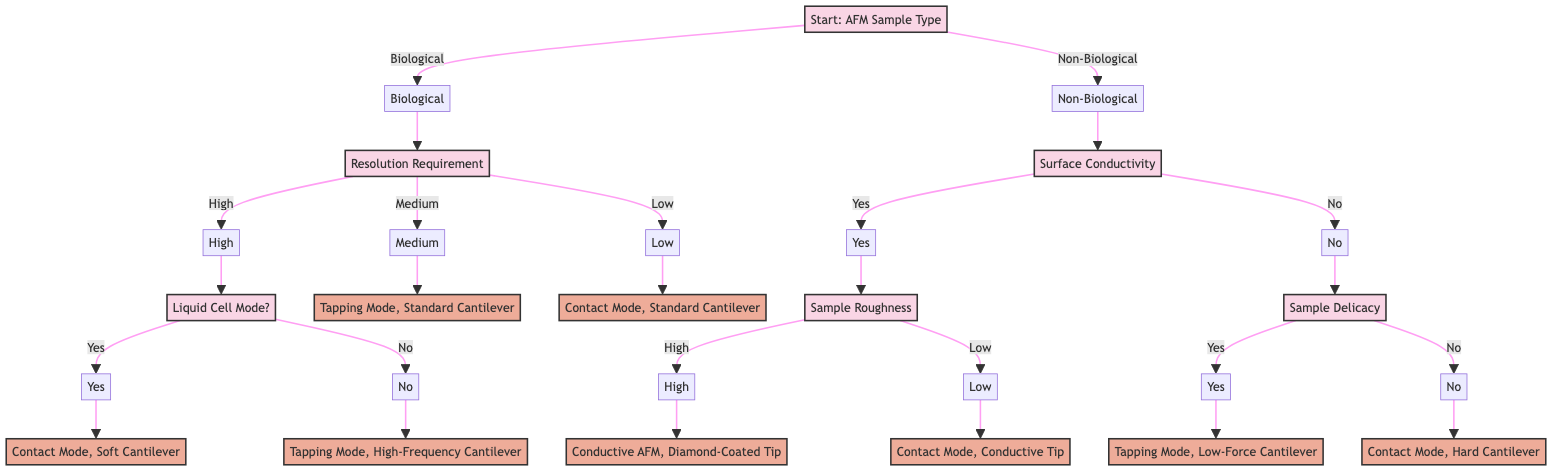What is the first question in the decision tree? The first question at the root node of the diagram asks about the type of sample being imaged, which can be either "Biological" or "Non-Biological."
Answer: What type of sample are you imaging? What are the resolution options available for biological samples? For biological samples, there are three resolution options listed: "High," "Medium," and "Low." Each of these options leads to different actions regarding AFM settings.
Answer: High, Medium, Low If the sample is non-biological and conductive, what does the tree ask next? After confirming that the sample is non-biological and conductive, the next question asked is about the roughness of the sample. This narrows down the AFM settings needed based on the roughness.
Answer: What is the roughness of the sample? What action is recommended for a high-resolution requirement in biological samples if liquid cell mode is not used? If the resolution requirement is high and liquid cell mode is not prepared to be used, the action recommended is to select Tapping Mode with a high-frequency cantilever.
Answer: Select Tapping Mode with a high-frequency cantilever How does the diagram differentiate between the treatment of delicate and non-delicate non-biological samples? The diagram asks if the non-biological sample is delicate or easily damaged. Depending on the response, a low-force cantilever is used for delicate samples, while a hard cantilever is used for non-delicate ones, thereby tailoring the imaging approach based on sample delicacy.
Answer: Yes or No (dependent on the answer) What is the action for a biological sample that requires medium resolution? For biological samples that require medium resolution, the recommended action is to use Tapping Mode with a standard cantilever. This option is specifically categorized in the resolution choices.
Answer: Use Tapping Mode with a standard cantilever If a non-biological sample is not conductive and not delicate, what is the recommended AFM mode? The decision tree suggests using Contact Mode with a hard cantilever for non-biological samples that are not conductive and not delicate, based on the specified conditions laid out in the path.
Answer: Use Contact Mode with a hard cantilever At which decision point does the choice of cantilever type occur for conductive non-biological samples? The choice of cantilever type occurs after determining that the sample is conductive and assessing the roughness of the sample, leading to the decision of using either a diamond-coated tip or a conductive tip.
Answer: After assessing sample roughness What types of cantilevers are suggested for different biological sample resolutions? For biological samples, the suggested cantilevers are: 'Soft cantilever' for high resolution with liquid cell mode, 'High-frequency cantilever' for high resolution without liquid cell mode, 'Standard cantilever' for medium resolution, and 'Standard cantilever' for low resolution.
Answer: Soft, High-frequency, Standard, Standard 